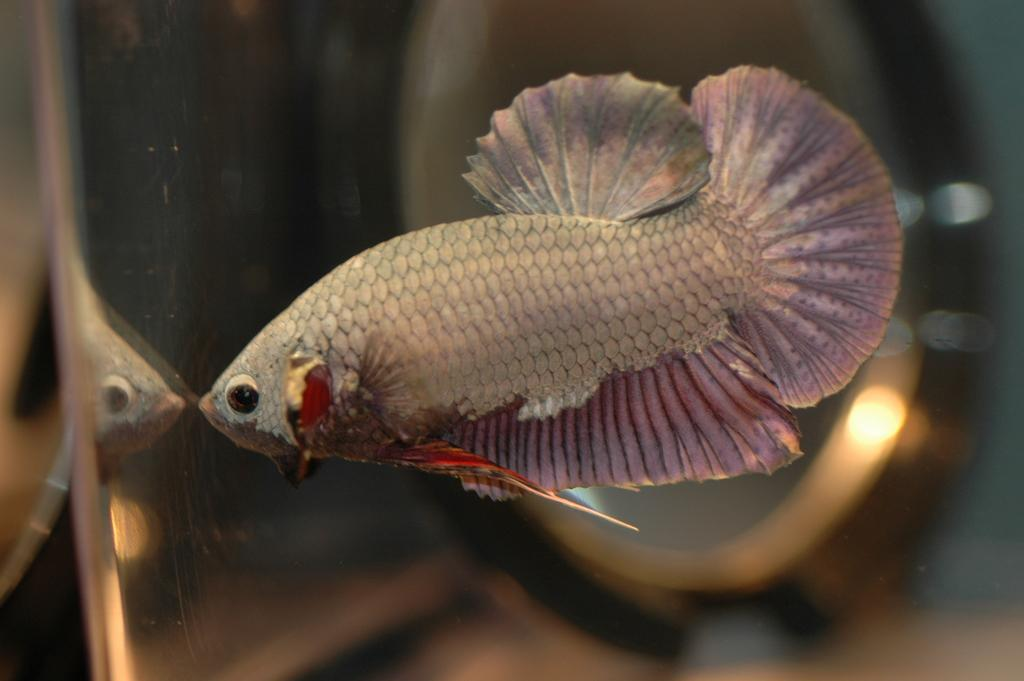What type of animals can be seen in the image? There are fish in the image. What object is present in the image that might be used for drinking? There is a glass in the image. What effect can be observed on the glass due to the presence of the fish? The reflection of the fish is visible on the glass. What can be inferred about the lighting conditions in the image? There is light in the image. How would you describe the background of the image? The background is blurred. What type of cream can be seen on the goldfish in the image? There is no cream or goldfish present in the image; it features fish and a glass with a reflection. What type of carriage is visible in the background of the image? There is no carriage present in the image; the background is blurred. 